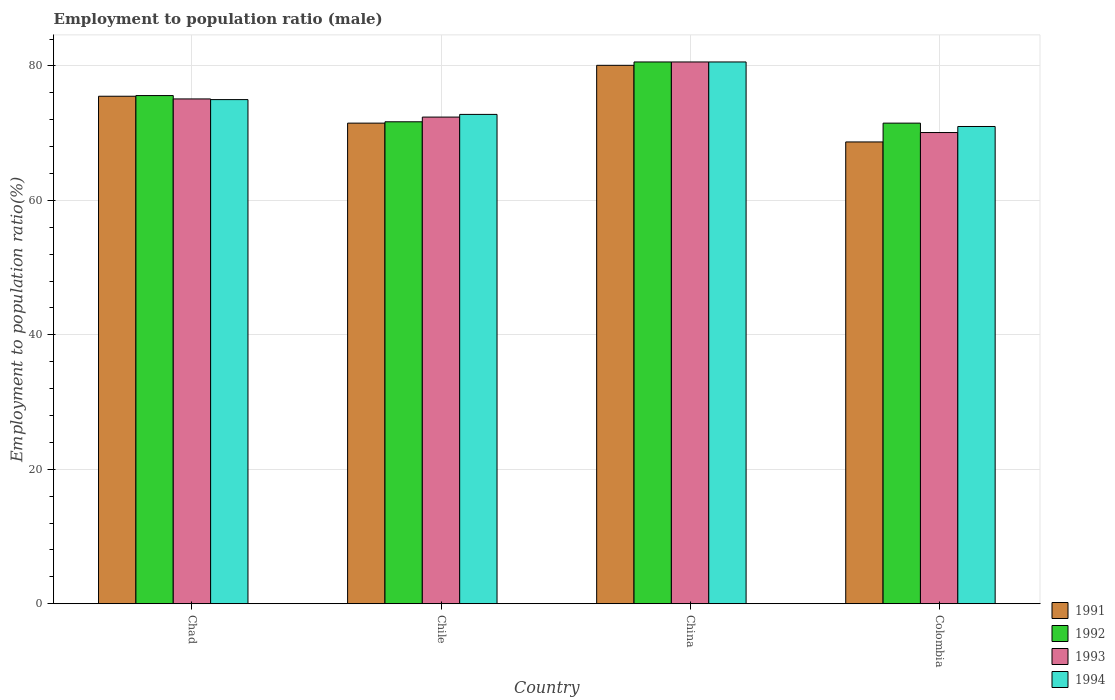How many groups of bars are there?
Offer a terse response. 4. Are the number of bars per tick equal to the number of legend labels?
Give a very brief answer. Yes. How many bars are there on the 1st tick from the left?
Keep it short and to the point. 4. How many bars are there on the 4th tick from the right?
Your answer should be compact. 4. What is the employment to population ratio in 1993 in China?
Your answer should be compact. 80.6. Across all countries, what is the maximum employment to population ratio in 1992?
Provide a succinct answer. 80.6. Across all countries, what is the minimum employment to population ratio in 1992?
Offer a terse response. 71.5. What is the total employment to population ratio in 1991 in the graph?
Provide a succinct answer. 295.8. What is the difference between the employment to population ratio in 1993 in Chad and that in China?
Offer a very short reply. -5.5. What is the difference between the employment to population ratio in 1993 in Chile and the employment to population ratio in 1994 in Colombia?
Your answer should be compact. 1.4. What is the average employment to population ratio in 1992 per country?
Make the answer very short. 74.85. What is the difference between the employment to population ratio of/in 1994 and employment to population ratio of/in 1992 in China?
Make the answer very short. 0. What is the ratio of the employment to population ratio in 1993 in Chile to that in Colombia?
Offer a very short reply. 1.03. What is the difference between the highest and the second highest employment to population ratio in 1991?
Your answer should be compact. 4.6. What is the difference between the highest and the lowest employment to population ratio in 1992?
Give a very brief answer. 9.1. Is the sum of the employment to population ratio in 1994 in Chile and Colombia greater than the maximum employment to population ratio in 1992 across all countries?
Provide a short and direct response. Yes. What does the 3rd bar from the right in Colombia represents?
Offer a terse response. 1992. Is it the case that in every country, the sum of the employment to population ratio in 1992 and employment to population ratio in 1991 is greater than the employment to population ratio in 1993?
Make the answer very short. Yes. How many countries are there in the graph?
Give a very brief answer. 4. Are the values on the major ticks of Y-axis written in scientific E-notation?
Your response must be concise. No. Does the graph contain grids?
Offer a terse response. Yes. How many legend labels are there?
Offer a terse response. 4. What is the title of the graph?
Give a very brief answer. Employment to population ratio (male). What is the label or title of the X-axis?
Your answer should be compact. Country. What is the label or title of the Y-axis?
Provide a short and direct response. Employment to population ratio(%). What is the Employment to population ratio(%) in 1991 in Chad?
Provide a short and direct response. 75.5. What is the Employment to population ratio(%) of 1992 in Chad?
Provide a succinct answer. 75.6. What is the Employment to population ratio(%) of 1993 in Chad?
Provide a short and direct response. 75.1. What is the Employment to population ratio(%) in 1991 in Chile?
Your answer should be compact. 71.5. What is the Employment to population ratio(%) of 1992 in Chile?
Your answer should be compact. 71.7. What is the Employment to population ratio(%) of 1993 in Chile?
Make the answer very short. 72.4. What is the Employment to population ratio(%) of 1994 in Chile?
Keep it short and to the point. 72.8. What is the Employment to population ratio(%) of 1991 in China?
Your answer should be very brief. 80.1. What is the Employment to population ratio(%) of 1992 in China?
Provide a short and direct response. 80.6. What is the Employment to population ratio(%) in 1993 in China?
Your answer should be very brief. 80.6. What is the Employment to population ratio(%) of 1994 in China?
Ensure brevity in your answer.  80.6. What is the Employment to population ratio(%) of 1991 in Colombia?
Provide a short and direct response. 68.7. What is the Employment to population ratio(%) of 1992 in Colombia?
Offer a terse response. 71.5. What is the Employment to population ratio(%) in 1993 in Colombia?
Offer a very short reply. 70.1. Across all countries, what is the maximum Employment to population ratio(%) of 1991?
Your response must be concise. 80.1. Across all countries, what is the maximum Employment to population ratio(%) of 1992?
Offer a terse response. 80.6. Across all countries, what is the maximum Employment to population ratio(%) of 1993?
Provide a succinct answer. 80.6. Across all countries, what is the maximum Employment to population ratio(%) in 1994?
Ensure brevity in your answer.  80.6. Across all countries, what is the minimum Employment to population ratio(%) of 1991?
Provide a short and direct response. 68.7. Across all countries, what is the minimum Employment to population ratio(%) in 1992?
Your answer should be compact. 71.5. Across all countries, what is the minimum Employment to population ratio(%) of 1993?
Your answer should be compact. 70.1. What is the total Employment to population ratio(%) of 1991 in the graph?
Make the answer very short. 295.8. What is the total Employment to population ratio(%) of 1992 in the graph?
Give a very brief answer. 299.4. What is the total Employment to population ratio(%) in 1993 in the graph?
Keep it short and to the point. 298.2. What is the total Employment to population ratio(%) of 1994 in the graph?
Ensure brevity in your answer.  299.4. What is the difference between the Employment to population ratio(%) of 1992 in Chad and that in Chile?
Provide a short and direct response. 3.9. What is the difference between the Employment to population ratio(%) in 1994 in Chad and that in Chile?
Your answer should be compact. 2.2. What is the difference between the Employment to population ratio(%) of 1991 in Chad and that in China?
Provide a short and direct response. -4.6. What is the difference between the Employment to population ratio(%) in 1992 in Chad and that in China?
Give a very brief answer. -5. What is the difference between the Employment to population ratio(%) of 1993 in Chad and that in China?
Provide a short and direct response. -5.5. What is the difference between the Employment to population ratio(%) of 1991 in Chad and that in Colombia?
Offer a very short reply. 6.8. What is the difference between the Employment to population ratio(%) in 1992 in Chad and that in Colombia?
Ensure brevity in your answer.  4.1. What is the difference between the Employment to population ratio(%) of 1993 in Chad and that in Colombia?
Ensure brevity in your answer.  5. What is the difference between the Employment to population ratio(%) of 1994 in Chad and that in Colombia?
Ensure brevity in your answer.  4. What is the difference between the Employment to population ratio(%) of 1992 in Chile and that in China?
Your answer should be very brief. -8.9. What is the difference between the Employment to population ratio(%) in 1993 in Chile and that in China?
Ensure brevity in your answer.  -8.2. What is the difference between the Employment to population ratio(%) of 1991 in Chile and that in Colombia?
Your response must be concise. 2.8. What is the difference between the Employment to population ratio(%) of 1993 in Chile and that in Colombia?
Provide a short and direct response. 2.3. What is the difference between the Employment to population ratio(%) of 1991 in China and that in Colombia?
Offer a terse response. 11.4. What is the difference between the Employment to population ratio(%) in 1994 in China and that in Colombia?
Offer a terse response. 9.6. What is the difference between the Employment to population ratio(%) of 1991 in Chad and the Employment to population ratio(%) of 1992 in Chile?
Give a very brief answer. 3.8. What is the difference between the Employment to population ratio(%) in 1991 in Chad and the Employment to population ratio(%) in 1993 in Chile?
Give a very brief answer. 3.1. What is the difference between the Employment to population ratio(%) of 1991 in Chad and the Employment to population ratio(%) of 1994 in Chile?
Provide a succinct answer. 2.7. What is the difference between the Employment to population ratio(%) in 1992 in Chad and the Employment to population ratio(%) in 1994 in Chile?
Offer a very short reply. 2.8. What is the difference between the Employment to population ratio(%) of 1993 in Chad and the Employment to population ratio(%) of 1994 in Chile?
Your answer should be very brief. 2.3. What is the difference between the Employment to population ratio(%) of 1991 in Chad and the Employment to population ratio(%) of 1993 in China?
Give a very brief answer. -5.1. What is the difference between the Employment to population ratio(%) in 1991 in Chad and the Employment to population ratio(%) in 1994 in China?
Your answer should be very brief. -5.1. What is the difference between the Employment to population ratio(%) of 1992 in Chad and the Employment to population ratio(%) of 1994 in China?
Your answer should be compact. -5. What is the difference between the Employment to population ratio(%) in 1993 in Chad and the Employment to population ratio(%) in 1994 in China?
Your answer should be very brief. -5.5. What is the difference between the Employment to population ratio(%) of 1991 in Chad and the Employment to population ratio(%) of 1992 in Colombia?
Your answer should be compact. 4. What is the difference between the Employment to population ratio(%) in 1991 in Chad and the Employment to population ratio(%) in 1993 in Colombia?
Ensure brevity in your answer.  5.4. What is the difference between the Employment to population ratio(%) in 1992 in Chad and the Employment to population ratio(%) in 1993 in Colombia?
Your answer should be very brief. 5.5. What is the difference between the Employment to population ratio(%) of 1993 in Chad and the Employment to population ratio(%) of 1994 in Colombia?
Offer a very short reply. 4.1. What is the difference between the Employment to population ratio(%) of 1991 in Chile and the Employment to population ratio(%) of 1992 in China?
Provide a succinct answer. -9.1. What is the difference between the Employment to population ratio(%) in 1991 in Chile and the Employment to population ratio(%) in 1993 in Colombia?
Offer a terse response. 1.4. What is the difference between the Employment to population ratio(%) in 1992 in Chile and the Employment to population ratio(%) in 1993 in Colombia?
Offer a terse response. 1.6. What is the difference between the Employment to population ratio(%) in 1992 in Chile and the Employment to population ratio(%) in 1994 in Colombia?
Offer a very short reply. 0.7. What is the difference between the Employment to population ratio(%) of 1991 in China and the Employment to population ratio(%) of 1994 in Colombia?
Provide a short and direct response. 9.1. What is the difference between the Employment to population ratio(%) of 1993 in China and the Employment to population ratio(%) of 1994 in Colombia?
Provide a succinct answer. 9.6. What is the average Employment to population ratio(%) in 1991 per country?
Ensure brevity in your answer.  73.95. What is the average Employment to population ratio(%) of 1992 per country?
Give a very brief answer. 74.85. What is the average Employment to population ratio(%) in 1993 per country?
Offer a very short reply. 74.55. What is the average Employment to population ratio(%) of 1994 per country?
Your answer should be very brief. 74.85. What is the difference between the Employment to population ratio(%) in 1991 and Employment to population ratio(%) in 1993 in Chad?
Your response must be concise. 0.4. What is the difference between the Employment to population ratio(%) of 1992 and Employment to population ratio(%) of 1993 in Chad?
Provide a succinct answer. 0.5. What is the difference between the Employment to population ratio(%) in 1993 and Employment to population ratio(%) in 1994 in Chad?
Provide a succinct answer. 0.1. What is the difference between the Employment to population ratio(%) of 1991 and Employment to population ratio(%) of 1992 in Chile?
Offer a very short reply. -0.2. What is the difference between the Employment to population ratio(%) in 1991 and Employment to population ratio(%) in 1994 in Chile?
Provide a succinct answer. -1.3. What is the difference between the Employment to population ratio(%) in 1992 and Employment to population ratio(%) in 1993 in Chile?
Make the answer very short. -0.7. What is the difference between the Employment to population ratio(%) of 1992 and Employment to population ratio(%) of 1994 in Chile?
Your answer should be very brief. -1.1. What is the difference between the Employment to population ratio(%) of 1991 and Employment to population ratio(%) of 1994 in China?
Provide a short and direct response. -0.5. What is the difference between the Employment to population ratio(%) in 1992 and Employment to population ratio(%) in 1993 in China?
Provide a succinct answer. 0. What is the difference between the Employment to population ratio(%) of 1993 and Employment to population ratio(%) of 1994 in China?
Your answer should be very brief. 0. What is the difference between the Employment to population ratio(%) of 1991 and Employment to population ratio(%) of 1993 in Colombia?
Provide a succinct answer. -1.4. What is the difference between the Employment to population ratio(%) in 1992 and Employment to population ratio(%) in 1993 in Colombia?
Give a very brief answer. 1.4. What is the ratio of the Employment to population ratio(%) of 1991 in Chad to that in Chile?
Provide a succinct answer. 1.06. What is the ratio of the Employment to population ratio(%) of 1992 in Chad to that in Chile?
Offer a terse response. 1.05. What is the ratio of the Employment to population ratio(%) in 1993 in Chad to that in Chile?
Your answer should be compact. 1.04. What is the ratio of the Employment to population ratio(%) of 1994 in Chad to that in Chile?
Your response must be concise. 1.03. What is the ratio of the Employment to population ratio(%) of 1991 in Chad to that in China?
Offer a terse response. 0.94. What is the ratio of the Employment to population ratio(%) in 1992 in Chad to that in China?
Your answer should be compact. 0.94. What is the ratio of the Employment to population ratio(%) in 1993 in Chad to that in China?
Ensure brevity in your answer.  0.93. What is the ratio of the Employment to population ratio(%) of 1994 in Chad to that in China?
Offer a very short reply. 0.93. What is the ratio of the Employment to population ratio(%) in 1991 in Chad to that in Colombia?
Make the answer very short. 1.1. What is the ratio of the Employment to population ratio(%) in 1992 in Chad to that in Colombia?
Provide a succinct answer. 1.06. What is the ratio of the Employment to population ratio(%) of 1993 in Chad to that in Colombia?
Offer a terse response. 1.07. What is the ratio of the Employment to population ratio(%) in 1994 in Chad to that in Colombia?
Your answer should be compact. 1.06. What is the ratio of the Employment to population ratio(%) in 1991 in Chile to that in China?
Offer a very short reply. 0.89. What is the ratio of the Employment to population ratio(%) of 1992 in Chile to that in China?
Keep it short and to the point. 0.89. What is the ratio of the Employment to population ratio(%) in 1993 in Chile to that in China?
Provide a succinct answer. 0.9. What is the ratio of the Employment to population ratio(%) in 1994 in Chile to that in China?
Offer a terse response. 0.9. What is the ratio of the Employment to population ratio(%) of 1991 in Chile to that in Colombia?
Provide a succinct answer. 1.04. What is the ratio of the Employment to population ratio(%) in 1993 in Chile to that in Colombia?
Give a very brief answer. 1.03. What is the ratio of the Employment to population ratio(%) of 1994 in Chile to that in Colombia?
Provide a succinct answer. 1.03. What is the ratio of the Employment to population ratio(%) in 1991 in China to that in Colombia?
Your answer should be compact. 1.17. What is the ratio of the Employment to population ratio(%) of 1992 in China to that in Colombia?
Provide a succinct answer. 1.13. What is the ratio of the Employment to population ratio(%) of 1993 in China to that in Colombia?
Your answer should be very brief. 1.15. What is the ratio of the Employment to population ratio(%) of 1994 in China to that in Colombia?
Ensure brevity in your answer.  1.14. What is the difference between the highest and the second highest Employment to population ratio(%) in 1991?
Ensure brevity in your answer.  4.6. What is the difference between the highest and the second highest Employment to population ratio(%) of 1994?
Make the answer very short. 5.6. What is the difference between the highest and the lowest Employment to population ratio(%) of 1993?
Make the answer very short. 10.5. What is the difference between the highest and the lowest Employment to population ratio(%) of 1994?
Offer a terse response. 9.6. 